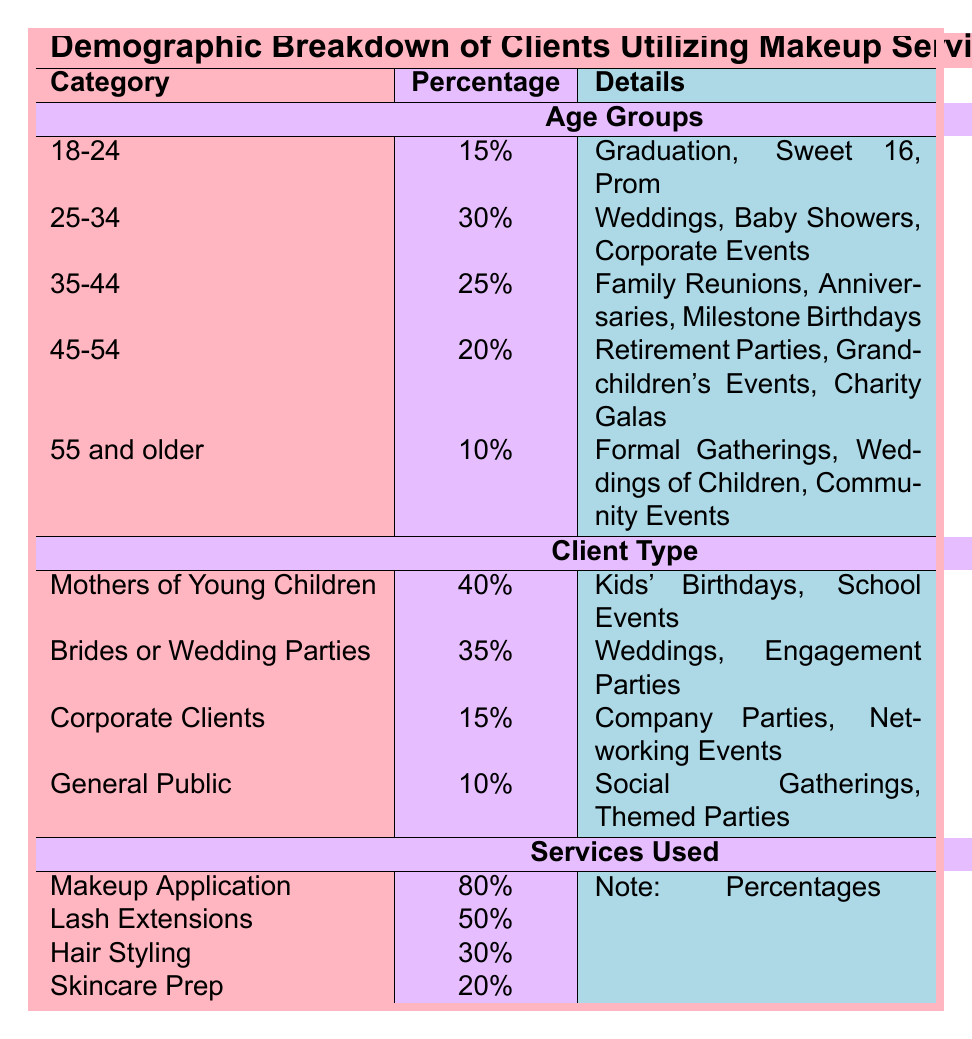What percentage of clients are aged 25-34? From the table, under the Age Groups section, the percentage of clients aged 25-34 is specified as 30%.
Answer: 30% Which client type has the highest percentage? The Client Type section shows that "Mothers of Young Children" have the highest percentage at 40%.
Answer: Mothers of Young Children If you combine the percentages of Makeup Application and Hair Styling, what total percentage do you get? Makeup Application has a percentage of 80% and Hair Styling has 30%. Adding these together gives 80 + 30 = 110%.
Answer: 110% Are there more clients aged 45-54 or those aged 55 and older? The table indicates that 20% of clients are aged 45-54 while only 10% are aged 55 and older. Thus, there are more clients in the 45-54 age group.
Answer: Yes What is the average percentage of clients in the age groups 35-44 and 45-54? The percentages for these age groups are 25% and 20%, respectively. To find the average, calculate (25 + 20) / 2, which equals 22.5%.
Answer: 22.5% Which services are utilized by a lower percentage of clients: Hair Styling or Skincare Prep? Hair Styling is used by 30% of clients and Skincare Prep is used by 20%. Since 20% is lower than 30%, Skincare Prep has a lower percentage.
Answer: Skincare Prep What types of events do the 45-54 age group typically attend? According to the table, individuals in the 45-54 age group typically attend Retirement Parties, Grandchildren's Events, and Charity Galas.
Answer: Retirement Parties, Grandchildren's Events, Charity Galas What percentage of clients are from the "General Public" category? The table indicates that the percentage of clients categorized as "General Public" is 10%.
Answer: 10% 